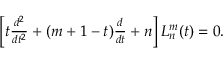<formula> <loc_0><loc_0><loc_500><loc_500>\begin{array} { r } { \left [ t \frac { d ^ { 2 } } { d t ^ { 2 } } + ( m + 1 - t ) \frac { d } { d t } + n \right ] L _ { n } ^ { m } ( t ) = 0 . } \end{array}</formula> 